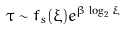<formula> <loc_0><loc_0><loc_500><loc_500>\tau \sim f _ { s } ( \xi ) e ^ { \beta \log _ { 2 } \xi }</formula> 